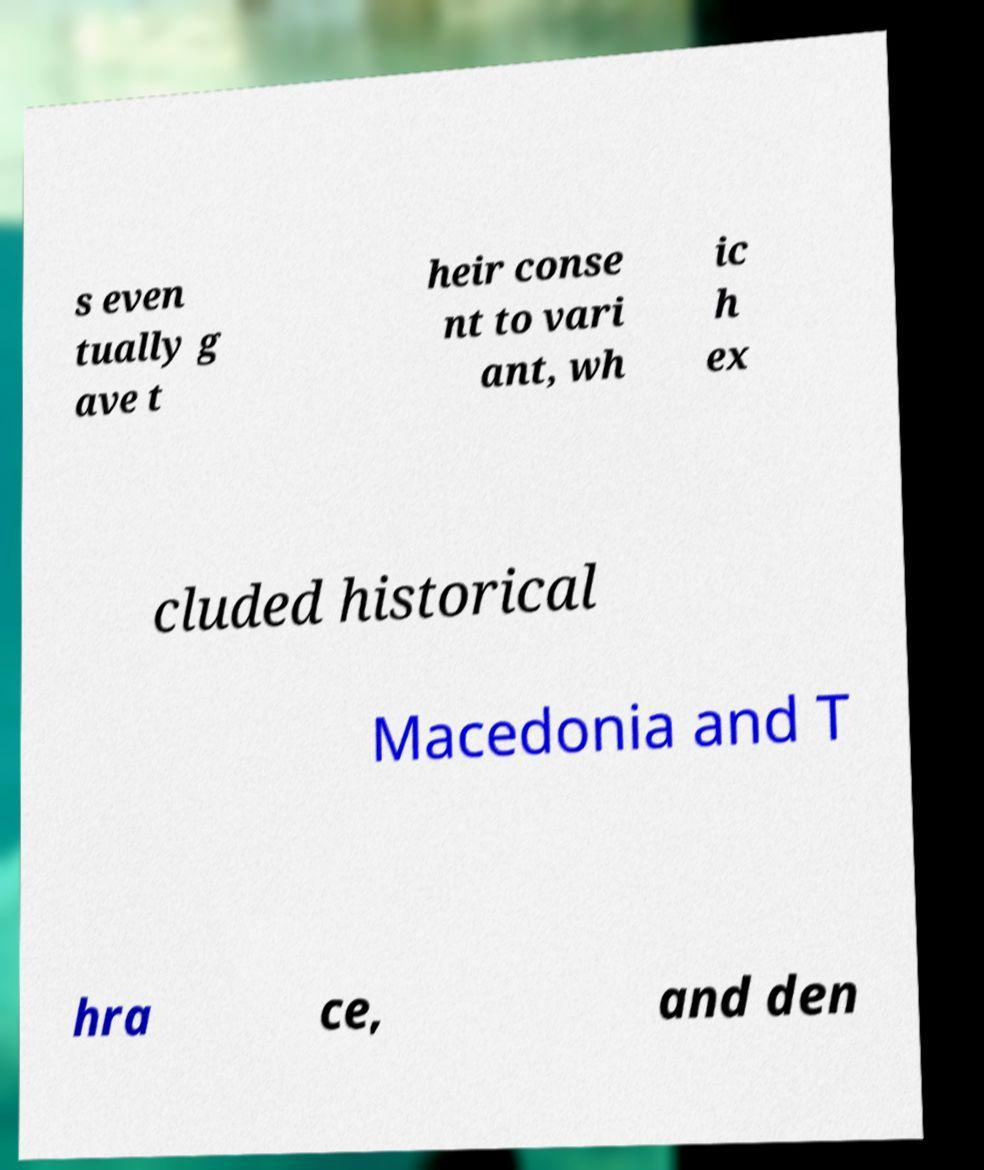Please identify and transcribe the text found in this image. s even tually g ave t heir conse nt to vari ant, wh ic h ex cluded historical Macedonia and T hra ce, and den 